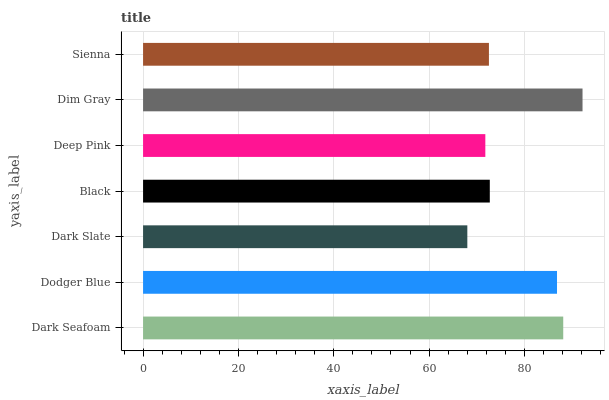Is Dark Slate the minimum?
Answer yes or no. Yes. Is Dim Gray the maximum?
Answer yes or no. Yes. Is Dodger Blue the minimum?
Answer yes or no. No. Is Dodger Blue the maximum?
Answer yes or no. No. Is Dark Seafoam greater than Dodger Blue?
Answer yes or no. Yes. Is Dodger Blue less than Dark Seafoam?
Answer yes or no. Yes. Is Dodger Blue greater than Dark Seafoam?
Answer yes or no. No. Is Dark Seafoam less than Dodger Blue?
Answer yes or no. No. Is Black the high median?
Answer yes or no. Yes. Is Black the low median?
Answer yes or no. Yes. Is Dim Gray the high median?
Answer yes or no. No. Is Deep Pink the low median?
Answer yes or no. No. 